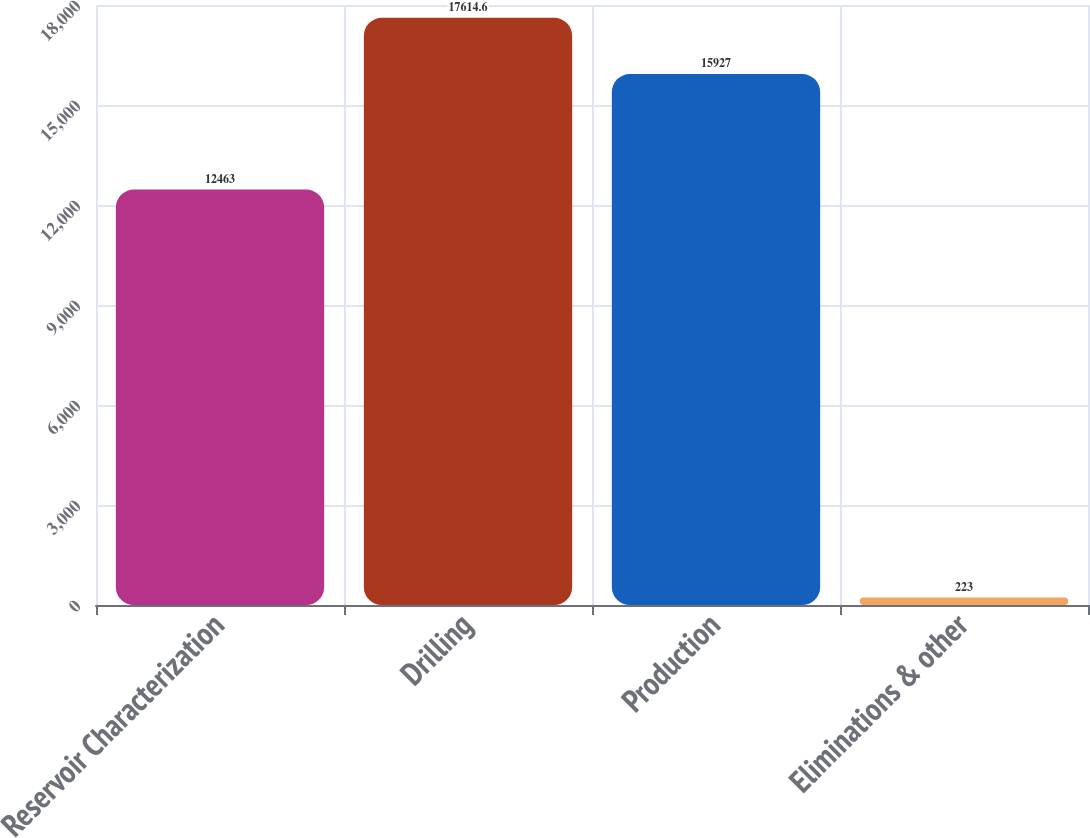Convert chart to OTSL. <chart><loc_0><loc_0><loc_500><loc_500><bar_chart><fcel>Reservoir Characterization<fcel>Drilling<fcel>Production<fcel>Eliminations & other<nl><fcel>12463<fcel>17614.6<fcel>15927<fcel>223<nl></chart> 